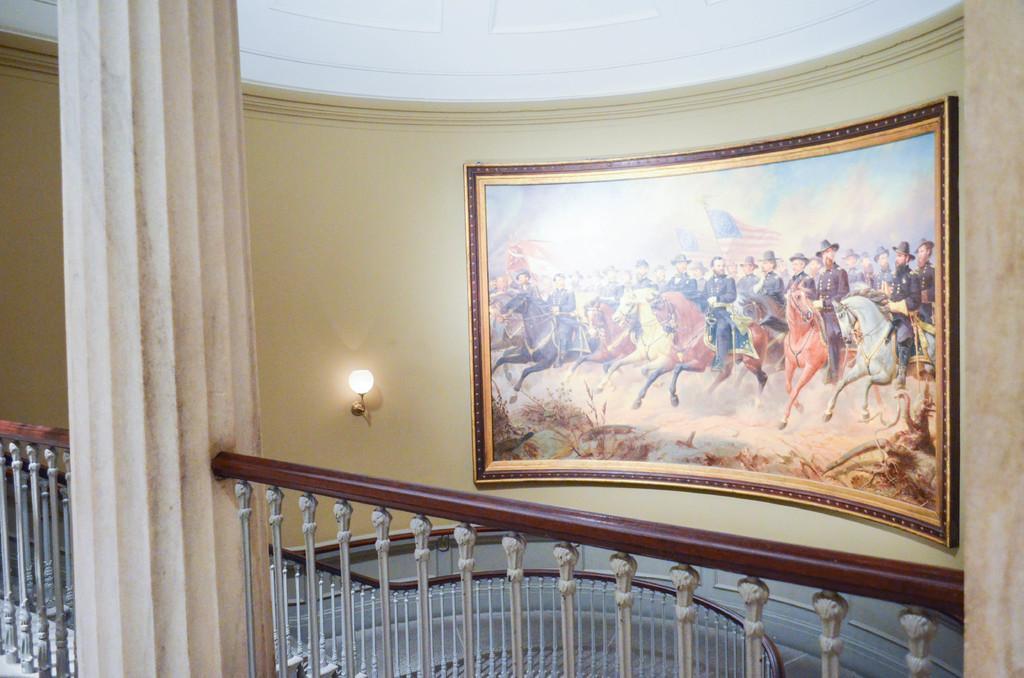Could you give a brief overview of what you see in this image? In this picture I can observe a railing. There is a pillar on the left side. I can observe a photo frame on the wall. In the photo frame I can observe some persons riding horses. In the background there is a wall. 